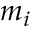Convert formula to latex. <formula><loc_0><loc_0><loc_500><loc_500>m _ { i }</formula> 